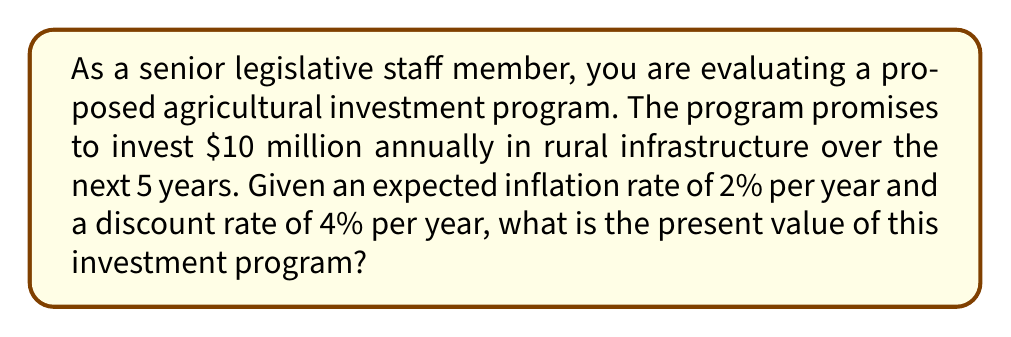Help me with this question. To solve this problem, we need to calculate the present value of a series of future cash flows, taking into account both inflation and the time value of money. We'll use the following steps:

1) First, we need to adjust the future cash flows for inflation. The real value of $10 million will decrease each year due to inflation.

2) Then, we'll calculate the present value of each inflation-adjusted cash flow using the discount rate.

3) Finally, we'll sum up all the present values to get the total present value of the investment program.

Let's go through this step-by-step:

1) Adjusting for inflation:
   Year 1: $10 million / (1 + 0.02)^1 = $9.80 million
   Year 2: $10 million / (1 + 0.02)^2 = $9.61 million
   Year 3: $10 million / (1 + 0.02)^3 = $9.42 million
   Year 4: $10 million / (1 + 0.02)^4 = $9.24 million
   Year 5: $10 million / (1 + 0.02)^5 = $9.06 million

2) Calculating present value of each cash flow:
   The present value formula is: $PV = FV / (1 + r)^n$
   Where FV is the future value, r is the discount rate, and n is the number of years.

   Year 1: $9.80 million / (1 + 0.04)^1 = $9.42 million
   Year 2: $9.61 million / (1 + 0.04)^2 = $8.88 million
   Year 3: $9.42 million / (1 + 0.04)^3 = $8.37 million
   Year 4: $9.24 million / (1 + 0.04)^4 = $7.89 million
   Year 5: $9.06 million / (1 + 0.04)^5 = $7.44 million

3) Sum up all present values:
   $9.42 + $8.88 + $8.37 + $7.89 + $7.44 = $42.00 million

Therefore, the present value of the investment program is $42.00 million.

We can express this mathematically as:

$$PV = \sum_{t=1}^{5} \frac{10,000,000}{(1 + 0.02)^t (1 + 0.04)^t}$$

Where $t$ represents the year of the cash flow.
Answer: $42.00 million 